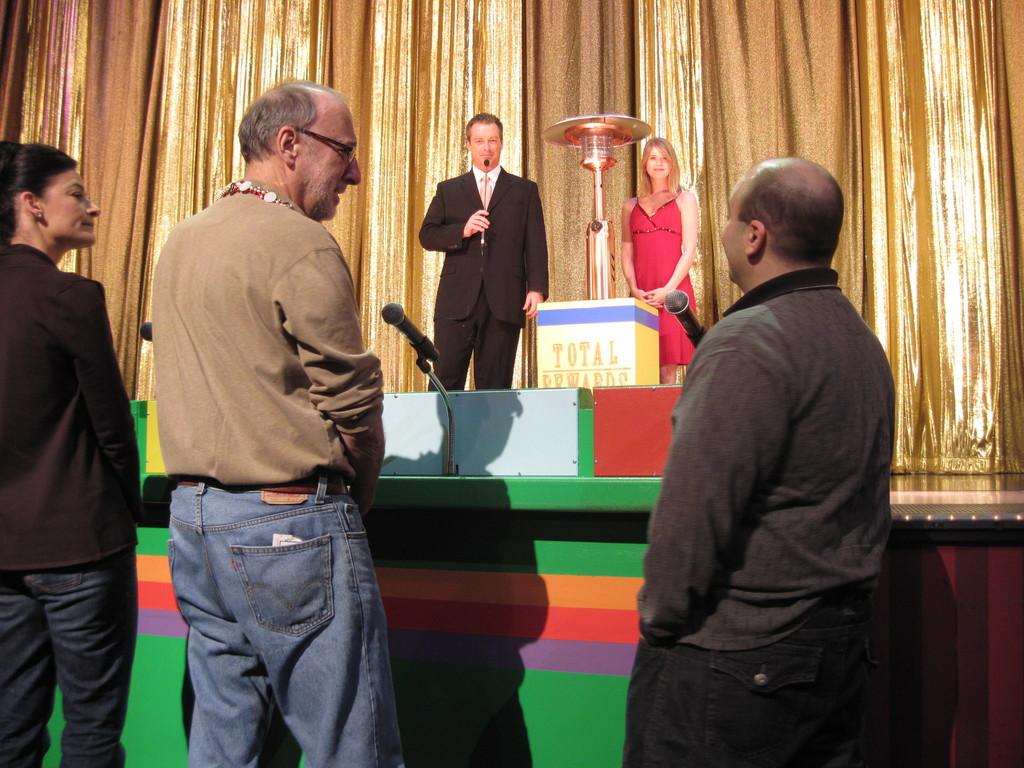What can be seen in the image involving people? There are persons standing in the image. What objects are present that might be used for amplifying sound? There are microphones in the image. What type of platform is visible in the image? There is a stage in the image. Are there any people on the stage? Yes, there are persons on the stage. What is the color and design of the curtains in the image? The curtains are gold and brown colored. What type of texture can be seen on the pancake in the image? There is no pancake present in the image; it features persons, microphones, a stage, and curtains. What type of blade is being used by the person on stage in the image? There is no blade visible in the image; it only shows persons, microphones, a stage, and curtains. 